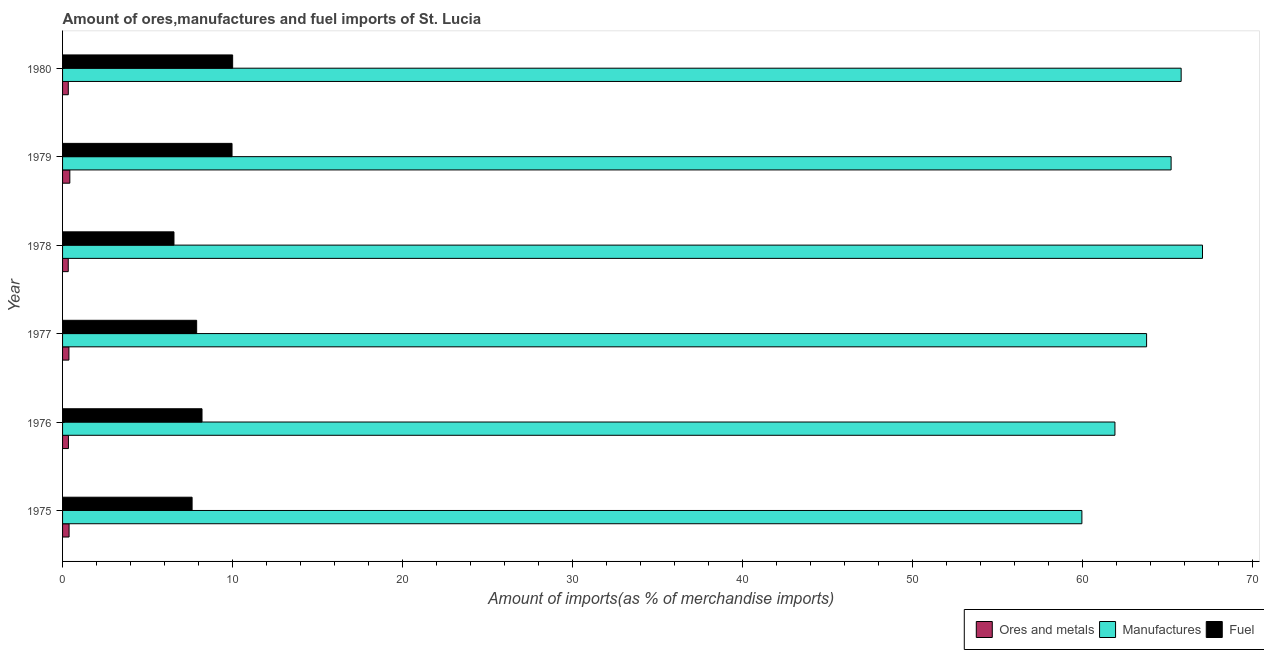How many different coloured bars are there?
Ensure brevity in your answer.  3. How many groups of bars are there?
Provide a short and direct response. 6. Are the number of bars per tick equal to the number of legend labels?
Keep it short and to the point. Yes. Are the number of bars on each tick of the Y-axis equal?
Your answer should be compact. Yes. How many bars are there on the 5th tick from the top?
Your answer should be very brief. 3. How many bars are there on the 2nd tick from the bottom?
Your response must be concise. 3. What is the label of the 6th group of bars from the top?
Offer a terse response. 1975. What is the percentage of manufactures imports in 1979?
Ensure brevity in your answer.  65.22. Across all years, what is the maximum percentage of manufactures imports?
Your response must be concise. 67.06. Across all years, what is the minimum percentage of fuel imports?
Provide a short and direct response. 6.55. In which year was the percentage of manufactures imports maximum?
Make the answer very short. 1978. In which year was the percentage of ores and metals imports minimum?
Provide a succinct answer. 1978. What is the total percentage of fuel imports in the graph?
Provide a succinct answer. 50.24. What is the difference between the percentage of fuel imports in 1975 and that in 1978?
Offer a terse response. 1.07. What is the difference between the percentage of fuel imports in 1978 and the percentage of manufactures imports in 1977?
Keep it short and to the point. -57.22. What is the average percentage of manufactures imports per year?
Give a very brief answer. 63.96. In the year 1976, what is the difference between the percentage of fuel imports and percentage of ores and metals imports?
Make the answer very short. 7.86. In how many years, is the percentage of ores and metals imports greater than 48 %?
Your response must be concise. 0. What is the ratio of the percentage of fuel imports in 1979 to that in 1980?
Your response must be concise. 1. Is the difference between the percentage of fuel imports in 1977 and 1980 greater than the difference between the percentage of manufactures imports in 1977 and 1980?
Provide a succinct answer. No. What is the difference between the highest and the second highest percentage of manufactures imports?
Your answer should be compact. 1.26. What is the difference between the highest and the lowest percentage of ores and metals imports?
Your response must be concise. 0.09. In how many years, is the percentage of ores and metals imports greater than the average percentage of ores and metals imports taken over all years?
Provide a short and direct response. 3. Is the sum of the percentage of ores and metals imports in 1975 and 1978 greater than the maximum percentage of manufactures imports across all years?
Offer a very short reply. No. What does the 1st bar from the top in 1977 represents?
Make the answer very short. Fuel. What does the 3rd bar from the bottom in 1980 represents?
Keep it short and to the point. Fuel. Is it the case that in every year, the sum of the percentage of ores and metals imports and percentage of manufactures imports is greater than the percentage of fuel imports?
Provide a short and direct response. Yes. What is the difference between two consecutive major ticks on the X-axis?
Offer a terse response. 10. Are the values on the major ticks of X-axis written in scientific E-notation?
Offer a terse response. No. Does the graph contain any zero values?
Offer a very short reply. No. How many legend labels are there?
Your answer should be compact. 3. What is the title of the graph?
Provide a short and direct response. Amount of ores,manufactures and fuel imports of St. Lucia. Does "Tertiary education" appear as one of the legend labels in the graph?
Make the answer very short. No. What is the label or title of the X-axis?
Provide a succinct answer. Amount of imports(as % of merchandise imports). What is the Amount of imports(as % of merchandise imports) in Ores and metals in 1975?
Offer a terse response. 0.38. What is the Amount of imports(as % of merchandise imports) in Manufactures in 1975?
Make the answer very short. 59.97. What is the Amount of imports(as % of merchandise imports) of Fuel in 1975?
Keep it short and to the point. 7.62. What is the Amount of imports(as % of merchandise imports) in Ores and metals in 1976?
Your answer should be very brief. 0.34. What is the Amount of imports(as % of merchandise imports) of Manufactures in 1976?
Your answer should be very brief. 61.91. What is the Amount of imports(as % of merchandise imports) in Fuel in 1976?
Ensure brevity in your answer.  8.2. What is the Amount of imports(as % of merchandise imports) of Ores and metals in 1977?
Ensure brevity in your answer.  0.37. What is the Amount of imports(as % of merchandise imports) in Manufactures in 1977?
Offer a terse response. 63.77. What is the Amount of imports(as % of merchandise imports) in Fuel in 1977?
Keep it short and to the point. 7.89. What is the Amount of imports(as % of merchandise imports) in Ores and metals in 1978?
Your response must be concise. 0.33. What is the Amount of imports(as % of merchandise imports) in Manufactures in 1978?
Provide a short and direct response. 67.06. What is the Amount of imports(as % of merchandise imports) of Fuel in 1978?
Your answer should be compact. 6.55. What is the Amount of imports(as % of merchandise imports) in Ores and metals in 1979?
Keep it short and to the point. 0.43. What is the Amount of imports(as % of merchandise imports) of Manufactures in 1979?
Provide a short and direct response. 65.22. What is the Amount of imports(as % of merchandise imports) in Fuel in 1979?
Provide a succinct answer. 9.97. What is the Amount of imports(as % of merchandise imports) in Ores and metals in 1980?
Your answer should be very brief. 0.34. What is the Amount of imports(as % of merchandise imports) of Manufactures in 1980?
Ensure brevity in your answer.  65.81. What is the Amount of imports(as % of merchandise imports) of Fuel in 1980?
Give a very brief answer. 10.01. Across all years, what is the maximum Amount of imports(as % of merchandise imports) in Ores and metals?
Your answer should be very brief. 0.43. Across all years, what is the maximum Amount of imports(as % of merchandise imports) in Manufactures?
Offer a terse response. 67.06. Across all years, what is the maximum Amount of imports(as % of merchandise imports) in Fuel?
Ensure brevity in your answer.  10.01. Across all years, what is the minimum Amount of imports(as % of merchandise imports) of Ores and metals?
Your answer should be compact. 0.33. Across all years, what is the minimum Amount of imports(as % of merchandise imports) of Manufactures?
Ensure brevity in your answer.  59.97. Across all years, what is the minimum Amount of imports(as % of merchandise imports) of Fuel?
Your answer should be compact. 6.55. What is the total Amount of imports(as % of merchandise imports) of Ores and metals in the graph?
Offer a very short reply. 2.2. What is the total Amount of imports(as % of merchandise imports) of Manufactures in the graph?
Ensure brevity in your answer.  383.74. What is the total Amount of imports(as % of merchandise imports) of Fuel in the graph?
Give a very brief answer. 50.24. What is the difference between the Amount of imports(as % of merchandise imports) in Ores and metals in 1975 and that in 1976?
Make the answer very short. 0.04. What is the difference between the Amount of imports(as % of merchandise imports) in Manufactures in 1975 and that in 1976?
Make the answer very short. -1.94. What is the difference between the Amount of imports(as % of merchandise imports) of Fuel in 1975 and that in 1976?
Your response must be concise. -0.58. What is the difference between the Amount of imports(as % of merchandise imports) of Ores and metals in 1975 and that in 1977?
Offer a terse response. 0.01. What is the difference between the Amount of imports(as % of merchandise imports) of Manufactures in 1975 and that in 1977?
Make the answer very short. -3.81. What is the difference between the Amount of imports(as % of merchandise imports) in Fuel in 1975 and that in 1977?
Provide a succinct answer. -0.27. What is the difference between the Amount of imports(as % of merchandise imports) of Ores and metals in 1975 and that in 1978?
Your answer should be very brief. 0.05. What is the difference between the Amount of imports(as % of merchandise imports) in Manufactures in 1975 and that in 1978?
Make the answer very short. -7.1. What is the difference between the Amount of imports(as % of merchandise imports) in Fuel in 1975 and that in 1978?
Your response must be concise. 1.07. What is the difference between the Amount of imports(as % of merchandise imports) of Ores and metals in 1975 and that in 1979?
Offer a terse response. -0.04. What is the difference between the Amount of imports(as % of merchandise imports) in Manufactures in 1975 and that in 1979?
Provide a succinct answer. -5.25. What is the difference between the Amount of imports(as % of merchandise imports) of Fuel in 1975 and that in 1979?
Your answer should be compact. -2.35. What is the difference between the Amount of imports(as % of merchandise imports) of Ores and metals in 1975 and that in 1980?
Make the answer very short. 0.05. What is the difference between the Amount of imports(as % of merchandise imports) in Manufactures in 1975 and that in 1980?
Make the answer very short. -5.84. What is the difference between the Amount of imports(as % of merchandise imports) in Fuel in 1975 and that in 1980?
Provide a succinct answer. -2.39. What is the difference between the Amount of imports(as % of merchandise imports) in Ores and metals in 1976 and that in 1977?
Provide a short and direct response. -0.03. What is the difference between the Amount of imports(as % of merchandise imports) in Manufactures in 1976 and that in 1977?
Give a very brief answer. -1.86. What is the difference between the Amount of imports(as % of merchandise imports) in Fuel in 1976 and that in 1977?
Keep it short and to the point. 0.32. What is the difference between the Amount of imports(as % of merchandise imports) of Ores and metals in 1976 and that in 1978?
Your response must be concise. 0.01. What is the difference between the Amount of imports(as % of merchandise imports) in Manufactures in 1976 and that in 1978?
Keep it short and to the point. -5.15. What is the difference between the Amount of imports(as % of merchandise imports) in Fuel in 1976 and that in 1978?
Offer a very short reply. 1.65. What is the difference between the Amount of imports(as % of merchandise imports) of Ores and metals in 1976 and that in 1979?
Make the answer very short. -0.08. What is the difference between the Amount of imports(as % of merchandise imports) in Manufactures in 1976 and that in 1979?
Offer a very short reply. -3.3. What is the difference between the Amount of imports(as % of merchandise imports) of Fuel in 1976 and that in 1979?
Ensure brevity in your answer.  -1.77. What is the difference between the Amount of imports(as % of merchandise imports) in Ores and metals in 1976 and that in 1980?
Your answer should be very brief. 0.01. What is the difference between the Amount of imports(as % of merchandise imports) of Manufactures in 1976 and that in 1980?
Ensure brevity in your answer.  -3.9. What is the difference between the Amount of imports(as % of merchandise imports) of Fuel in 1976 and that in 1980?
Ensure brevity in your answer.  -1.8. What is the difference between the Amount of imports(as % of merchandise imports) of Ores and metals in 1977 and that in 1978?
Your response must be concise. 0.04. What is the difference between the Amount of imports(as % of merchandise imports) of Manufactures in 1977 and that in 1978?
Your response must be concise. -3.29. What is the difference between the Amount of imports(as % of merchandise imports) in Fuel in 1977 and that in 1978?
Give a very brief answer. 1.33. What is the difference between the Amount of imports(as % of merchandise imports) of Ores and metals in 1977 and that in 1979?
Your answer should be compact. -0.05. What is the difference between the Amount of imports(as % of merchandise imports) of Manufactures in 1977 and that in 1979?
Your answer should be very brief. -1.44. What is the difference between the Amount of imports(as % of merchandise imports) of Fuel in 1977 and that in 1979?
Provide a short and direct response. -2.08. What is the difference between the Amount of imports(as % of merchandise imports) in Ores and metals in 1977 and that in 1980?
Your answer should be compact. 0.04. What is the difference between the Amount of imports(as % of merchandise imports) of Manufactures in 1977 and that in 1980?
Ensure brevity in your answer.  -2.03. What is the difference between the Amount of imports(as % of merchandise imports) of Fuel in 1977 and that in 1980?
Your response must be concise. -2.12. What is the difference between the Amount of imports(as % of merchandise imports) of Ores and metals in 1978 and that in 1979?
Give a very brief answer. -0.09. What is the difference between the Amount of imports(as % of merchandise imports) in Manufactures in 1978 and that in 1979?
Your response must be concise. 1.85. What is the difference between the Amount of imports(as % of merchandise imports) of Fuel in 1978 and that in 1979?
Your answer should be compact. -3.42. What is the difference between the Amount of imports(as % of merchandise imports) of Ores and metals in 1978 and that in 1980?
Provide a short and direct response. -0. What is the difference between the Amount of imports(as % of merchandise imports) in Manufactures in 1978 and that in 1980?
Your answer should be compact. 1.26. What is the difference between the Amount of imports(as % of merchandise imports) of Fuel in 1978 and that in 1980?
Offer a very short reply. -3.45. What is the difference between the Amount of imports(as % of merchandise imports) of Ores and metals in 1979 and that in 1980?
Your answer should be compact. 0.09. What is the difference between the Amount of imports(as % of merchandise imports) of Manufactures in 1979 and that in 1980?
Provide a succinct answer. -0.59. What is the difference between the Amount of imports(as % of merchandise imports) in Fuel in 1979 and that in 1980?
Keep it short and to the point. -0.04. What is the difference between the Amount of imports(as % of merchandise imports) of Ores and metals in 1975 and the Amount of imports(as % of merchandise imports) of Manufactures in 1976?
Your answer should be compact. -61.53. What is the difference between the Amount of imports(as % of merchandise imports) in Ores and metals in 1975 and the Amount of imports(as % of merchandise imports) in Fuel in 1976?
Offer a very short reply. -7.82. What is the difference between the Amount of imports(as % of merchandise imports) in Manufactures in 1975 and the Amount of imports(as % of merchandise imports) in Fuel in 1976?
Make the answer very short. 51.76. What is the difference between the Amount of imports(as % of merchandise imports) in Ores and metals in 1975 and the Amount of imports(as % of merchandise imports) in Manufactures in 1977?
Give a very brief answer. -63.39. What is the difference between the Amount of imports(as % of merchandise imports) in Ores and metals in 1975 and the Amount of imports(as % of merchandise imports) in Fuel in 1977?
Your answer should be compact. -7.51. What is the difference between the Amount of imports(as % of merchandise imports) in Manufactures in 1975 and the Amount of imports(as % of merchandise imports) in Fuel in 1977?
Ensure brevity in your answer.  52.08. What is the difference between the Amount of imports(as % of merchandise imports) in Ores and metals in 1975 and the Amount of imports(as % of merchandise imports) in Manufactures in 1978?
Offer a very short reply. -66.68. What is the difference between the Amount of imports(as % of merchandise imports) of Ores and metals in 1975 and the Amount of imports(as % of merchandise imports) of Fuel in 1978?
Give a very brief answer. -6.17. What is the difference between the Amount of imports(as % of merchandise imports) in Manufactures in 1975 and the Amount of imports(as % of merchandise imports) in Fuel in 1978?
Ensure brevity in your answer.  53.41. What is the difference between the Amount of imports(as % of merchandise imports) in Ores and metals in 1975 and the Amount of imports(as % of merchandise imports) in Manufactures in 1979?
Give a very brief answer. -64.83. What is the difference between the Amount of imports(as % of merchandise imports) in Ores and metals in 1975 and the Amount of imports(as % of merchandise imports) in Fuel in 1979?
Offer a terse response. -9.59. What is the difference between the Amount of imports(as % of merchandise imports) in Manufactures in 1975 and the Amount of imports(as % of merchandise imports) in Fuel in 1979?
Provide a succinct answer. 50. What is the difference between the Amount of imports(as % of merchandise imports) of Ores and metals in 1975 and the Amount of imports(as % of merchandise imports) of Manufactures in 1980?
Offer a very short reply. -65.42. What is the difference between the Amount of imports(as % of merchandise imports) of Ores and metals in 1975 and the Amount of imports(as % of merchandise imports) of Fuel in 1980?
Provide a short and direct response. -9.62. What is the difference between the Amount of imports(as % of merchandise imports) of Manufactures in 1975 and the Amount of imports(as % of merchandise imports) of Fuel in 1980?
Keep it short and to the point. 49.96. What is the difference between the Amount of imports(as % of merchandise imports) of Ores and metals in 1976 and the Amount of imports(as % of merchandise imports) of Manufactures in 1977?
Give a very brief answer. -63.43. What is the difference between the Amount of imports(as % of merchandise imports) of Ores and metals in 1976 and the Amount of imports(as % of merchandise imports) of Fuel in 1977?
Offer a very short reply. -7.54. What is the difference between the Amount of imports(as % of merchandise imports) of Manufactures in 1976 and the Amount of imports(as % of merchandise imports) of Fuel in 1977?
Offer a very short reply. 54.02. What is the difference between the Amount of imports(as % of merchandise imports) in Ores and metals in 1976 and the Amount of imports(as % of merchandise imports) in Manufactures in 1978?
Offer a very short reply. -66.72. What is the difference between the Amount of imports(as % of merchandise imports) in Ores and metals in 1976 and the Amount of imports(as % of merchandise imports) in Fuel in 1978?
Offer a terse response. -6.21. What is the difference between the Amount of imports(as % of merchandise imports) of Manufactures in 1976 and the Amount of imports(as % of merchandise imports) of Fuel in 1978?
Keep it short and to the point. 55.36. What is the difference between the Amount of imports(as % of merchandise imports) in Ores and metals in 1976 and the Amount of imports(as % of merchandise imports) in Manufactures in 1979?
Ensure brevity in your answer.  -64.87. What is the difference between the Amount of imports(as % of merchandise imports) of Ores and metals in 1976 and the Amount of imports(as % of merchandise imports) of Fuel in 1979?
Keep it short and to the point. -9.62. What is the difference between the Amount of imports(as % of merchandise imports) in Manufactures in 1976 and the Amount of imports(as % of merchandise imports) in Fuel in 1979?
Your response must be concise. 51.94. What is the difference between the Amount of imports(as % of merchandise imports) in Ores and metals in 1976 and the Amount of imports(as % of merchandise imports) in Manufactures in 1980?
Offer a terse response. -65.46. What is the difference between the Amount of imports(as % of merchandise imports) of Ores and metals in 1976 and the Amount of imports(as % of merchandise imports) of Fuel in 1980?
Ensure brevity in your answer.  -9.66. What is the difference between the Amount of imports(as % of merchandise imports) of Manufactures in 1976 and the Amount of imports(as % of merchandise imports) of Fuel in 1980?
Offer a very short reply. 51.91. What is the difference between the Amount of imports(as % of merchandise imports) in Ores and metals in 1977 and the Amount of imports(as % of merchandise imports) in Manufactures in 1978?
Keep it short and to the point. -66.69. What is the difference between the Amount of imports(as % of merchandise imports) in Ores and metals in 1977 and the Amount of imports(as % of merchandise imports) in Fuel in 1978?
Your response must be concise. -6.18. What is the difference between the Amount of imports(as % of merchandise imports) of Manufactures in 1977 and the Amount of imports(as % of merchandise imports) of Fuel in 1978?
Give a very brief answer. 57.22. What is the difference between the Amount of imports(as % of merchandise imports) of Ores and metals in 1977 and the Amount of imports(as % of merchandise imports) of Manufactures in 1979?
Your answer should be compact. -64.84. What is the difference between the Amount of imports(as % of merchandise imports) in Ores and metals in 1977 and the Amount of imports(as % of merchandise imports) in Fuel in 1979?
Offer a terse response. -9.6. What is the difference between the Amount of imports(as % of merchandise imports) in Manufactures in 1977 and the Amount of imports(as % of merchandise imports) in Fuel in 1979?
Keep it short and to the point. 53.81. What is the difference between the Amount of imports(as % of merchandise imports) of Ores and metals in 1977 and the Amount of imports(as % of merchandise imports) of Manufactures in 1980?
Offer a terse response. -65.43. What is the difference between the Amount of imports(as % of merchandise imports) of Ores and metals in 1977 and the Amount of imports(as % of merchandise imports) of Fuel in 1980?
Offer a terse response. -9.63. What is the difference between the Amount of imports(as % of merchandise imports) of Manufactures in 1977 and the Amount of imports(as % of merchandise imports) of Fuel in 1980?
Offer a terse response. 53.77. What is the difference between the Amount of imports(as % of merchandise imports) in Ores and metals in 1978 and the Amount of imports(as % of merchandise imports) in Manufactures in 1979?
Offer a very short reply. -64.88. What is the difference between the Amount of imports(as % of merchandise imports) of Ores and metals in 1978 and the Amount of imports(as % of merchandise imports) of Fuel in 1979?
Offer a terse response. -9.64. What is the difference between the Amount of imports(as % of merchandise imports) of Manufactures in 1978 and the Amount of imports(as % of merchandise imports) of Fuel in 1979?
Provide a short and direct response. 57.09. What is the difference between the Amount of imports(as % of merchandise imports) in Ores and metals in 1978 and the Amount of imports(as % of merchandise imports) in Manufactures in 1980?
Provide a succinct answer. -65.47. What is the difference between the Amount of imports(as % of merchandise imports) in Ores and metals in 1978 and the Amount of imports(as % of merchandise imports) in Fuel in 1980?
Your response must be concise. -9.67. What is the difference between the Amount of imports(as % of merchandise imports) of Manufactures in 1978 and the Amount of imports(as % of merchandise imports) of Fuel in 1980?
Provide a short and direct response. 57.06. What is the difference between the Amount of imports(as % of merchandise imports) in Ores and metals in 1979 and the Amount of imports(as % of merchandise imports) in Manufactures in 1980?
Offer a very short reply. -65.38. What is the difference between the Amount of imports(as % of merchandise imports) in Ores and metals in 1979 and the Amount of imports(as % of merchandise imports) in Fuel in 1980?
Keep it short and to the point. -9.58. What is the difference between the Amount of imports(as % of merchandise imports) of Manufactures in 1979 and the Amount of imports(as % of merchandise imports) of Fuel in 1980?
Give a very brief answer. 55.21. What is the average Amount of imports(as % of merchandise imports) in Ores and metals per year?
Offer a very short reply. 0.37. What is the average Amount of imports(as % of merchandise imports) of Manufactures per year?
Keep it short and to the point. 63.96. What is the average Amount of imports(as % of merchandise imports) in Fuel per year?
Your answer should be compact. 8.37. In the year 1975, what is the difference between the Amount of imports(as % of merchandise imports) of Ores and metals and Amount of imports(as % of merchandise imports) of Manufactures?
Your answer should be compact. -59.58. In the year 1975, what is the difference between the Amount of imports(as % of merchandise imports) in Ores and metals and Amount of imports(as % of merchandise imports) in Fuel?
Offer a terse response. -7.24. In the year 1975, what is the difference between the Amount of imports(as % of merchandise imports) of Manufactures and Amount of imports(as % of merchandise imports) of Fuel?
Ensure brevity in your answer.  52.35. In the year 1976, what is the difference between the Amount of imports(as % of merchandise imports) of Ores and metals and Amount of imports(as % of merchandise imports) of Manufactures?
Make the answer very short. -61.57. In the year 1976, what is the difference between the Amount of imports(as % of merchandise imports) in Ores and metals and Amount of imports(as % of merchandise imports) in Fuel?
Your response must be concise. -7.86. In the year 1976, what is the difference between the Amount of imports(as % of merchandise imports) of Manufactures and Amount of imports(as % of merchandise imports) of Fuel?
Offer a very short reply. 53.71. In the year 1977, what is the difference between the Amount of imports(as % of merchandise imports) of Ores and metals and Amount of imports(as % of merchandise imports) of Manufactures?
Provide a short and direct response. -63.4. In the year 1977, what is the difference between the Amount of imports(as % of merchandise imports) in Ores and metals and Amount of imports(as % of merchandise imports) in Fuel?
Keep it short and to the point. -7.51. In the year 1977, what is the difference between the Amount of imports(as % of merchandise imports) of Manufactures and Amount of imports(as % of merchandise imports) of Fuel?
Keep it short and to the point. 55.89. In the year 1978, what is the difference between the Amount of imports(as % of merchandise imports) of Ores and metals and Amount of imports(as % of merchandise imports) of Manufactures?
Provide a succinct answer. -66.73. In the year 1978, what is the difference between the Amount of imports(as % of merchandise imports) of Ores and metals and Amount of imports(as % of merchandise imports) of Fuel?
Keep it short and to the point. -6.22. In the year 1978, what is the difference between the Amount of imports(as % of merchandise imports) of Manufactures and Amount of imports(as % of merchandise imports) of Fuel?
Ensure brevity in your answer.  60.51. In the year 1979, what is the difference between the Amount of imports(as % of merchandise imports) in Ores and metals and Amount of imports(as % of merchandise imports) in Manufactures?
Provide a succinct answer. -64.79. In the year 1979, what is the difference between the Amount of imports(as % of merchandise imports) of Ores and metals and Amount of imports(as % of merchandise imports) of Fuel?
Provide a succinct answer. -9.54. In the year 1979, what is the difference between the Amount of imports(as % of merchandise imports) of Manufactures and Amount of imports(as % of merchandise imports) of Fuel?
Ensure brevity in your answer.  55.25. In the year 1980, what is the difference between the Amount of imports(as % of merchandise imports) in Ores and metals and Amount of imports(as % of merchandise imports) in Manufactures?
Your response must be concise. -65.47. In the year 1980, what is the difference between the Amount of imports(as % of merchandise imports) in Ores and metals and Amount of imports(as % of merchandise imports) in Fuel?
Your answer should be very brief. -9.67. In the year 1980, what is the difference between the Amount of imports(as % of merchandise imports) of Manufactures and Amount of imports(as % of merchandise imports) of Fuel?
Provide a succinct answer. 55.8. What is the ratio of the Amount of imports(as % of merchandise imports) of Ores and metals in 1975 to that in 1976?
Offer a terse response. 1.11. What is the ratio of the Amount of imports(as % of merchandise imports) in Manufactures in 1975 to that in 1976?
Make the answer very short. 0.97. What is the ratio of the Amount of imports(as % of merchandise imports) in Fuel in 1975 to that in 1976?
Offer a very short reply. 0.93. What is the ratio of the Amount of imports(as % of merchandise imports) in Ores and metals in 1975 to that in 1977?
Offer a terse response. 1.02. What is the ratio of the Amount of imports(as % of merchandise imports) of Manufactures in 1975 to that in 1977?
Provide a succinct answer. 0.94. What is the ratio of the Amount of imports(as % of merchandise imports) of Fuel in 1975 to that in 1977?
Give a very brief answer. 0.97. What is the ratio of the Amount of imports(as % of merchandise imports) of Ores and metals in 1975 to that in 1978?
Keep it short and to the point. 1.15. What is the ratio of the Amount of imports(as % of merchandise imports) of Manufactures in 1975 to that in 1978?
Provide a short and direct response. 0.89. What is the ratio of the Amount of imports(as % of merchandise imports) in Fuel in 1975 to that in 1978?
Offer a very short reply. 1.16. What is the ratio of the Amount of imports(as % of merchandise imports) of Ores and metals in 1975 to that in 1979?
Offer a very short reply. 0.9. What is the ratio of the Amount of imports(as % of merchandise imports) in Manufactures in 1975 to that in 1979?
Provide a short and direct response. 0.92. What is the ratio of the Amount of imports(as % of merchandise imports) of Fuel in 1975 to that in 1979?
Offer a very short reply. 0.76. What is the ratio of the Amount of imports(as % of merchandise imports) of Ores and metals in 1975 to that in 1980?
Make the answer very short. 1.13. What is the ratio of the Amount of imports(as % of merchandise imports) in Manufactures in 1975 to that in 1980?
Offer a terse response. 0.91. What is the ratio of the Amount of imports(as % of merchandise imports) in Fuel in 1975 to that in 1980?
Make the answer very short. 0.76. What is the ratio of the Amount of imports(as % of merchandise imports) in Ores and metals in 1976 to that in 1977?
Your answer should be very brief. 0.92. What is the ratio of the Amount of imports(as % of merchandise imports) in Manufactures in 1976 to that in 1977?
Your response must be concise. 0.97. What is the ratio of the Amount of imports(as % of merchandise imports) of Fuel in 1976 to that in 1977?
Offer a very short reply. 1.04. What is the ratio of the Amount of imports(as % of merchandise imports) in Ores and metals in 1976 to that in 1978?
Give a very brief answer. 1.03. What is the ratio of the Amount of imports(as % of merchandise imports) of Manufactures in 1976 to that in 1978?
Provide a succinct answer. 0.92. What is the ratio of the Amount of imports(as % of merchandise imports) of Fuel in 1976 to that in 1978?
Ensure brevity in your answer.  1.25. What is the ratio of the Amount of imports(as % of merchandise imports) in Ores and metals in 1976 to that in 1979?
Give a very brief answer. 0.81. What is the ratio of the Amount of imports(as % of merchandise imports) in Manufactures in 1976 to that in 1979?
Ensure brevity in your answer.  0.95. What is the ratio of the Amount of imports(as % of merchandise imports) in Fuel in 1976 to that in 1979?
Give a very brief answer. 0.82. What is the ratio of the Amount of imports(as % of merchandise imports) of Ores and metals in 1976 to that in 1980?
Your answer should be compact. 1.02. What is the ratio of the Amount of imports(as % of merchandise imports) of Manufactures in 1976 to that in 1980?
Keep it short and to the point. 0.94. What is the ratio of the Amount of imports(as % of merchandise imports) in Fuel in 1976 to that in 1980?
Make the answer very short. 0.82. What is the ratio of the Amount of imports(as % of merchandise imports) in Ores and metals in 1977 to that in 1978?
Make the answer very short. 1.12. What is the ratio of the Amount of imports(as % of merchandise imports) in Manufactures in 1977 to that in 1978?
Offer a terse response. 0.95. What is the ratio of the Amount of imports(as % of merchandise imports) in Fuel in 1977 to that in 1978?
Make the answer very short. 1.2. What is the ratio of the Amount of imports(as % of merchandise imports) of Ores and metals in 1977 to that in 1979?
Provide a short and direct response. 0.88. What is the ratio of the Amount of imports(as % of merchandise imports) of Manufactures in 1977 to that in 1979?
Offer a terse response. 0.98. What is the ratio of the Amount of imports(as % of merchandise imports) in Fuel in 1977 to that in 1979?
Your response must be concise. 0.79. What is the ratio of the Amount of imports(as % of merchandise imports) in Ores and metals in 1977 to that in 1980?
Your answer should be compact. 1.11. What is the ratio of the Amount of imports(as % of merchandise imports) of Manufactures in 1977 to that in 1980?
Ensure brevity in your answer.  0.97. What is the ratio of the Amount of imports(as % of merchandise imports) of Fuel in 1977 to that in 1980?
Your answer should be very brief. 0.79. What is the ratio of the Amount of imports(as % of merchandise imports) of Ores and metals in 1978 to that in 1979?
Your answer should be very brief. 0.78. What is the ratio of the Amount of imports(as % of merchandise imports) of Manufactures in 1978 to that in 1979?
Your answer should be compact. 1.03. What is the ratio of the Amount of imports(as % of merchandise imports) of Fuel in 1978 to that in 1979?
Your response must be concise. 0.66. What is the ratio of the Amount of imports(as % of merchandise imports) in Ores and metals in 1978 to that in 1980?
Ensure brevity in your answer.  0.99. What is the ratio of the Amount of imports(as % of merchandise imports) of Manufactures in 1978 to that in 1980?
Provide a short and direct response. 1.02. What is the ratio of the Amount of imports(as % of merchandise imports) of Fuel in 1978 to that in 1980?
Your answer should be compact. 0.66. What is the ratio of the Amount of imports(as % of merchandise imports) of Ores and metals in 1979 to that in 1980?
Your answer should be compact. 1.27. What is the ratio of the Amount of imports(as % of merchandise imports) of Manufactures in 1979 to that in 1980?
Offer a very short reply. 0.99. What is the difference between the highest and the second highest Amount of imports(as % of merchandise imports) of Ores and metals?
Provide a short and direct response. 0.04. What is the difference between the highest and the second highest Amount of imports(as % of merchandise imports) in Manufactures?
Offer a very short reply. 1.26. What is the difference between the highest and the second highest Amount of imports(as % of merchandise imports) in Fuel?
Your response must be concise. 0.04. What is the difference between the highest and the lowest Amount of imports(as % of merchandise imports) in Ores and metals?
Keep it short and to the point. 0.09. What is the difference between the highest and the lowest Amount of imports(as % of merchandise imports) of Manufactures?
Ensure brevity in your answer.  7.1. What is the difference between the highest and the lowest Amount of imports(as % of merchandise imports) in Fuel?
Make the answer very short. 3.45. 